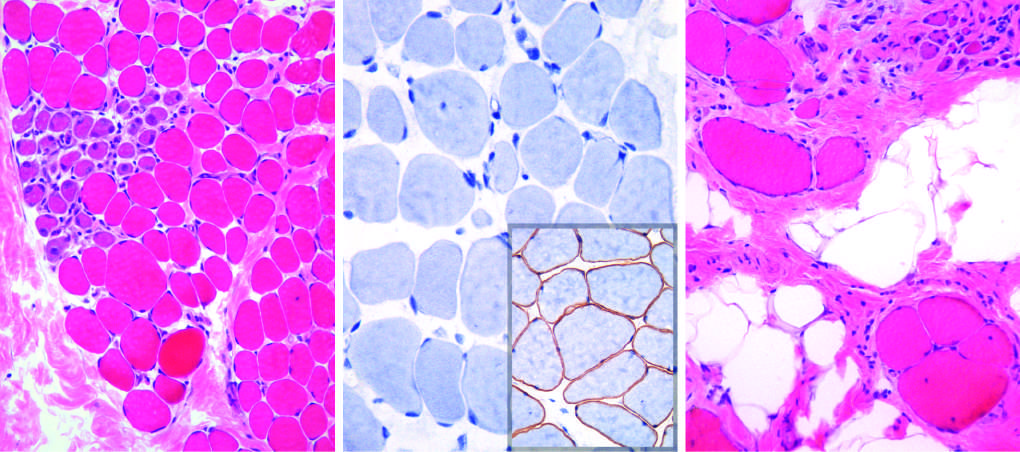what is maintained at a younger age?
Answer the question using a single word or phrase. Fascicular muscle architecture 